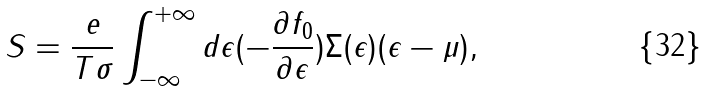Convert formula to latex. <formula><loc_0><loc_0><loc_500><loc_500>S = \frac { e } { T \sigma } \int ^ { + \infty } _ { - \infty } d \epsilon ( - \frac { \partial f _ { 0 } } { \partial \epsilon } ) \Sigma ( \epsilon ) ( \epsilon - \mu ) ,</formula> 